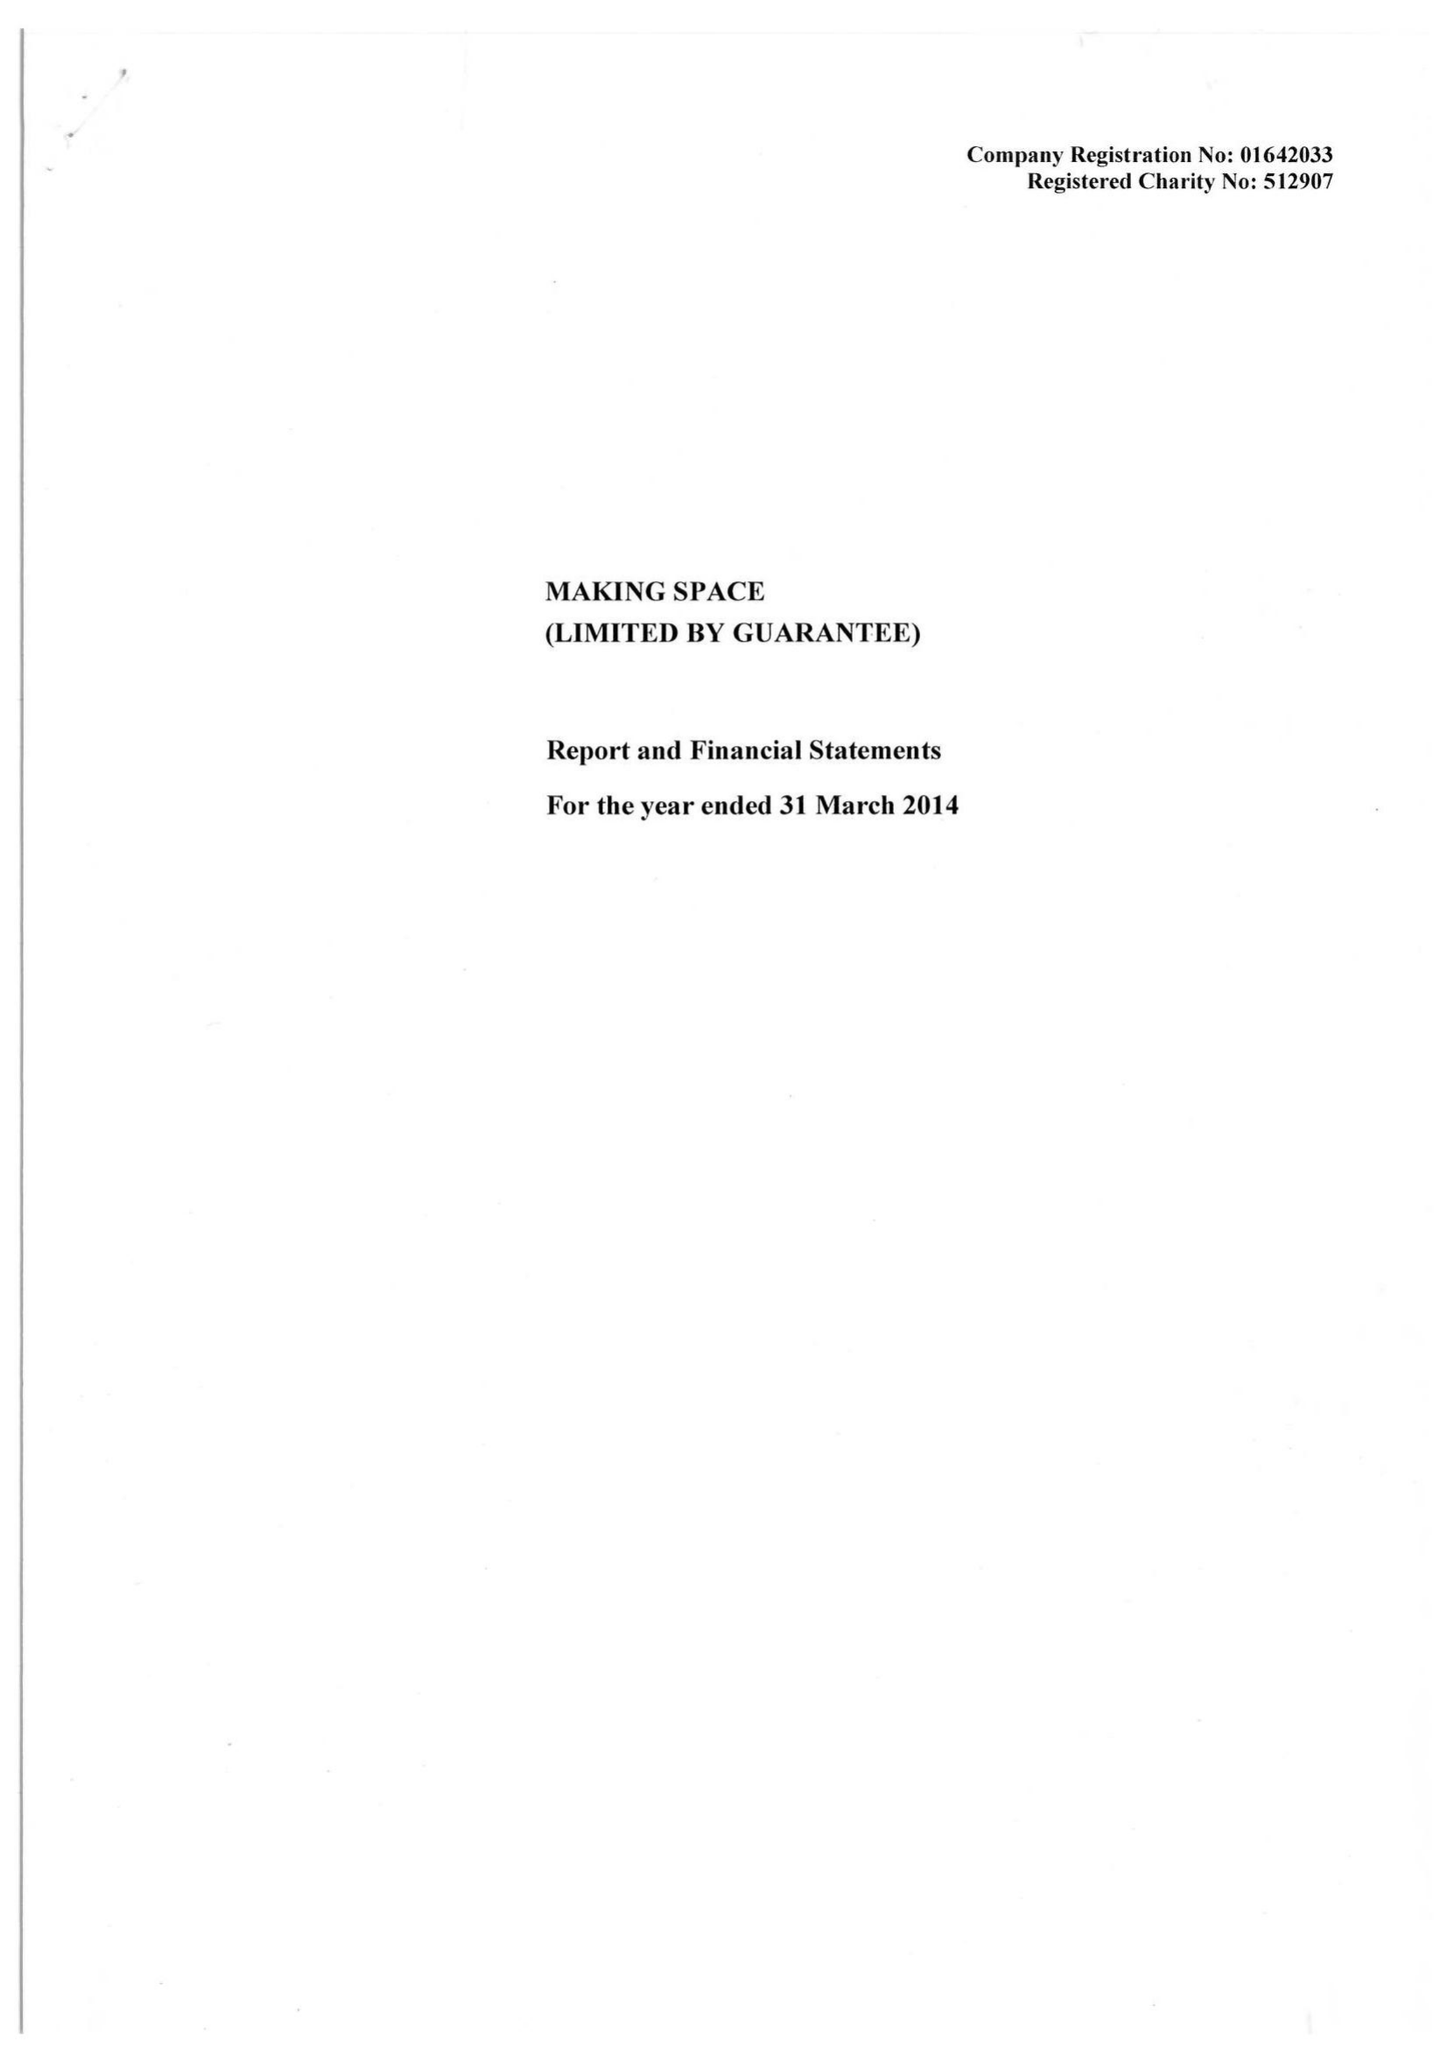What is the value for the address__street_line?
Answer the question using a single word or phrase. 46 ALLEN STREET 